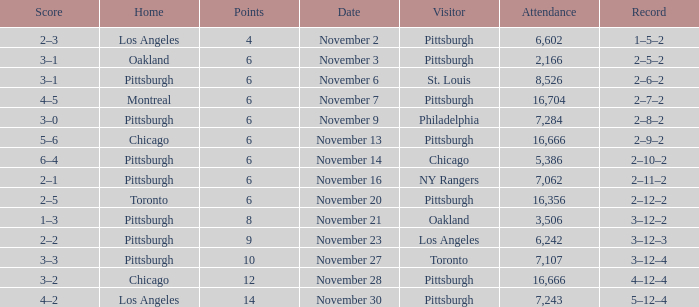What is the sum of the points of the game with philadelphia as the visitor and an attendance greater than 7,284? None. 